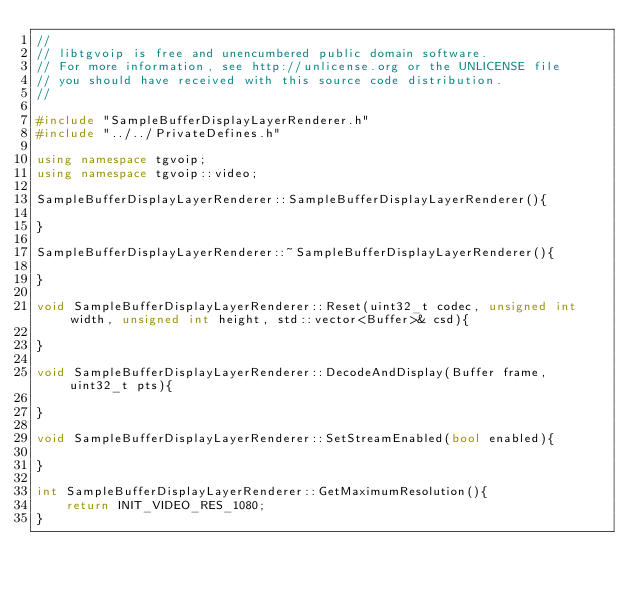<code> <loc_0><loc_0><loc_500><loc_500><_C++_>//
// libtgvoip is free and unencumbered public domain software.
// For more information, see http://unlicense.org or the UNLICENSE file
// you should have received with this source code distribution.
//

#include "SampleBufferDisplayLayerRenderer.h"
#include "../../PrivateDefines.h"

using namespace tgvoip;
using namespace tgvoip::video;

SampleBufferDisplayLayerRenderer::SampleBufferDisplayLayerRenderer(){

}

SampleBufferDisplayLayerRenderer::~SampleBufferDisplayLayerRenderer(){

}

void SampleBufferDisplayLayerRenderer::Reset(uint32_t codec, unsigned int width, unsigned int height, std::vector<Buffer>& csd){

}

void SampleBufferDisplayLayerRenderer::DecodeAndDisplay(Buffer frame, uint32_t pts){

}

void SampleBufferDisplayLayerRenderer::SetStreamEnabled(bool enabled){

}

int SampleBufferDisplayLayerRenderer::GetMaximumResolution(){
	return INIT_VIDEO_RES_1080;
}
</code> 